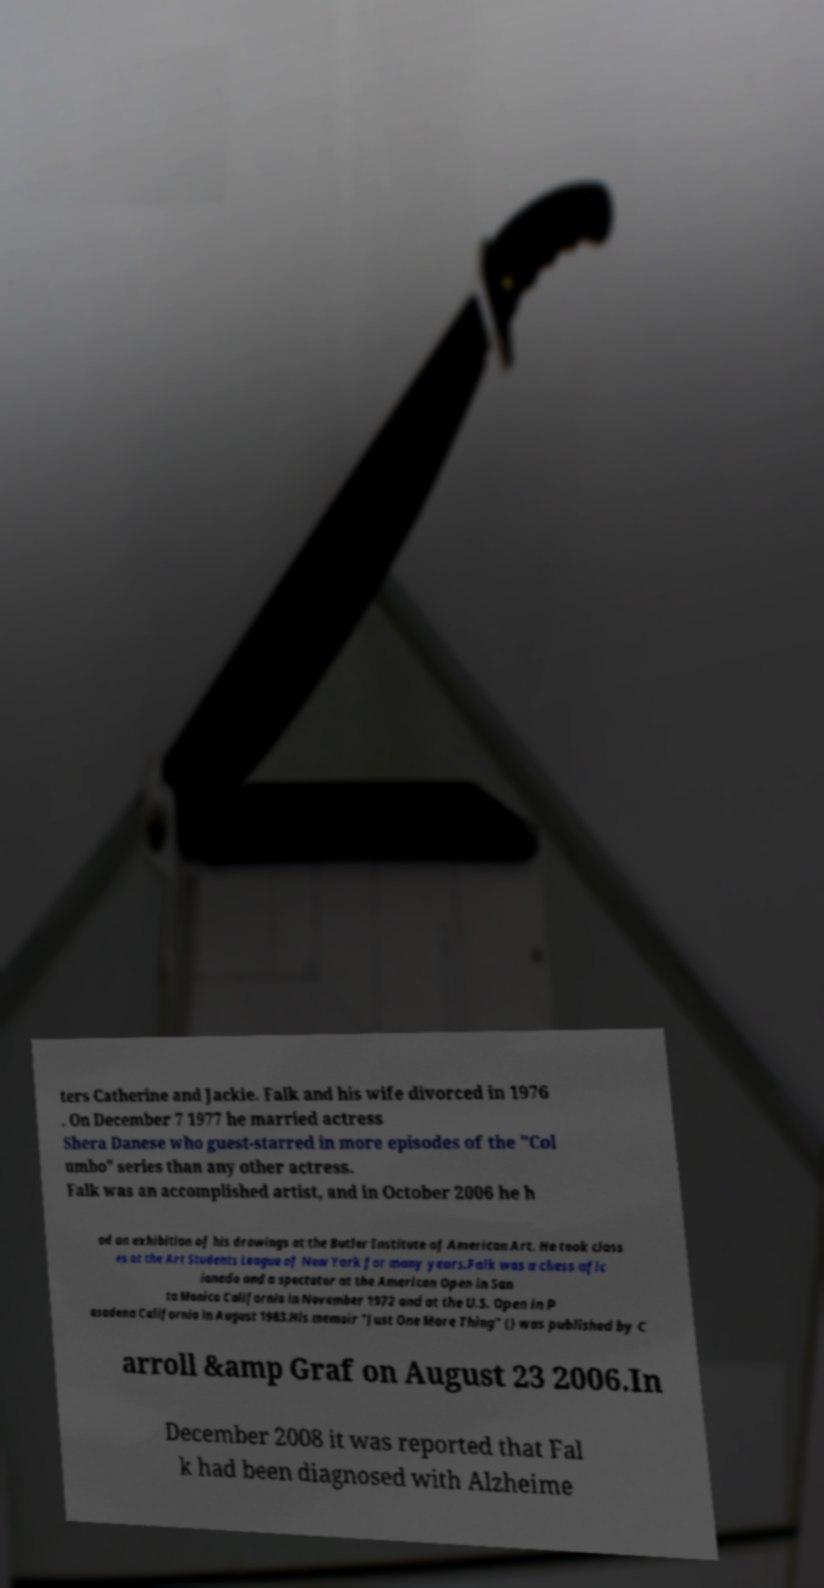I need the written content from this picture converted into text. Can you do that? ters Catherine and Jackie. Falk and his wife divorced in 1976 . On December 7 1977 he married actress Shera Danese who guest-starred in more episodes of the "Col umbo" series than any other actress. Falk was an accomplished artist, and in October 2006 he h ad an exhibition of his drawings at the Butler Institute of American Art. He took class es at the Art Students League of New York for many years.Falk was a chess afic ionado and a spectator at the American Open in San ta Monica California in November 1972 and at the U.S. Open in P asadena California in August 1983.His memoir "Just One More Thing" () was published by C arroll &amp Graf on August 23 2006.In December 2008 it was reported that Fal k had been diagnosed with Alzheime 